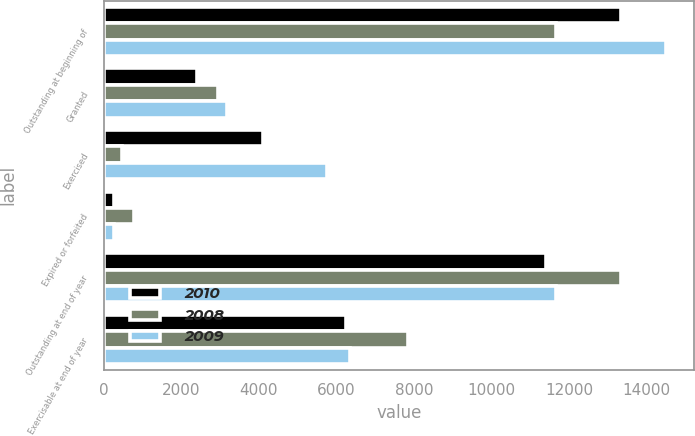<chart> <loc_0><loc_0><loc_500><loc_500><stacked_bar_chart><ecel><fcel>Outstanding at beginning of<fcel>Granted<fcel>Exercised<fcel>Expired or forfeited<fcel>Outstanding at end of year<fcel>Exercisable at end of year<nl><fcel>2010<fcel>13347<fcel>2420<fcel>4107<fcel>268<fcel>11392<fcel>6256<nl><fcel>2008<fcel>11651<fcel>2955<fcel>476<fcel>783<fcel>13347<fcel>7839<nl><fcel>2009<fcel>14495<fcel>3177<fcel>5753<fcel>268<fcel>11651<fcel>6345<nl></chart> 